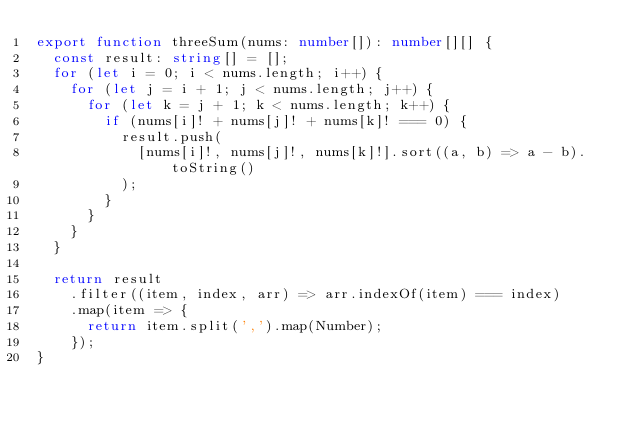Convert code to text. <code><loc_0><loc_0><loc_500><loc_500><_TypeScript_>export function threeSum(nums: number[]): number[][] {
  const result: string[] = [];
  for (let i = 0; i < nums.length; i++) {
    for (let j = i + 1; j < nums.length; j++) {
      for (let k = j + 1; k < nums.length; k++) {
        if (nums[i]! + nums[j]! + nums[k]! === 0) {
          result.push(
            [nums[i]!, nums[j]!, nums[k]!].sort((a, b) => a - b).toString()
          );
        }
      }
    }
  }

  return result
    .filter((item, index, arr) => arr.indexOf(item) === index)
    .map(item => {
      return item.split(',').map(Number);
    });
}
</code> 